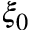Convert formula to latex. <formula><loc_0><loc_0><loc_500><loc_500>\xi _ { 0 }</formula> 